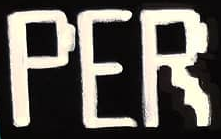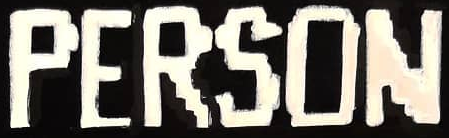What text appears in these images from left to right, separated by a semicolon? PER; PERSON 